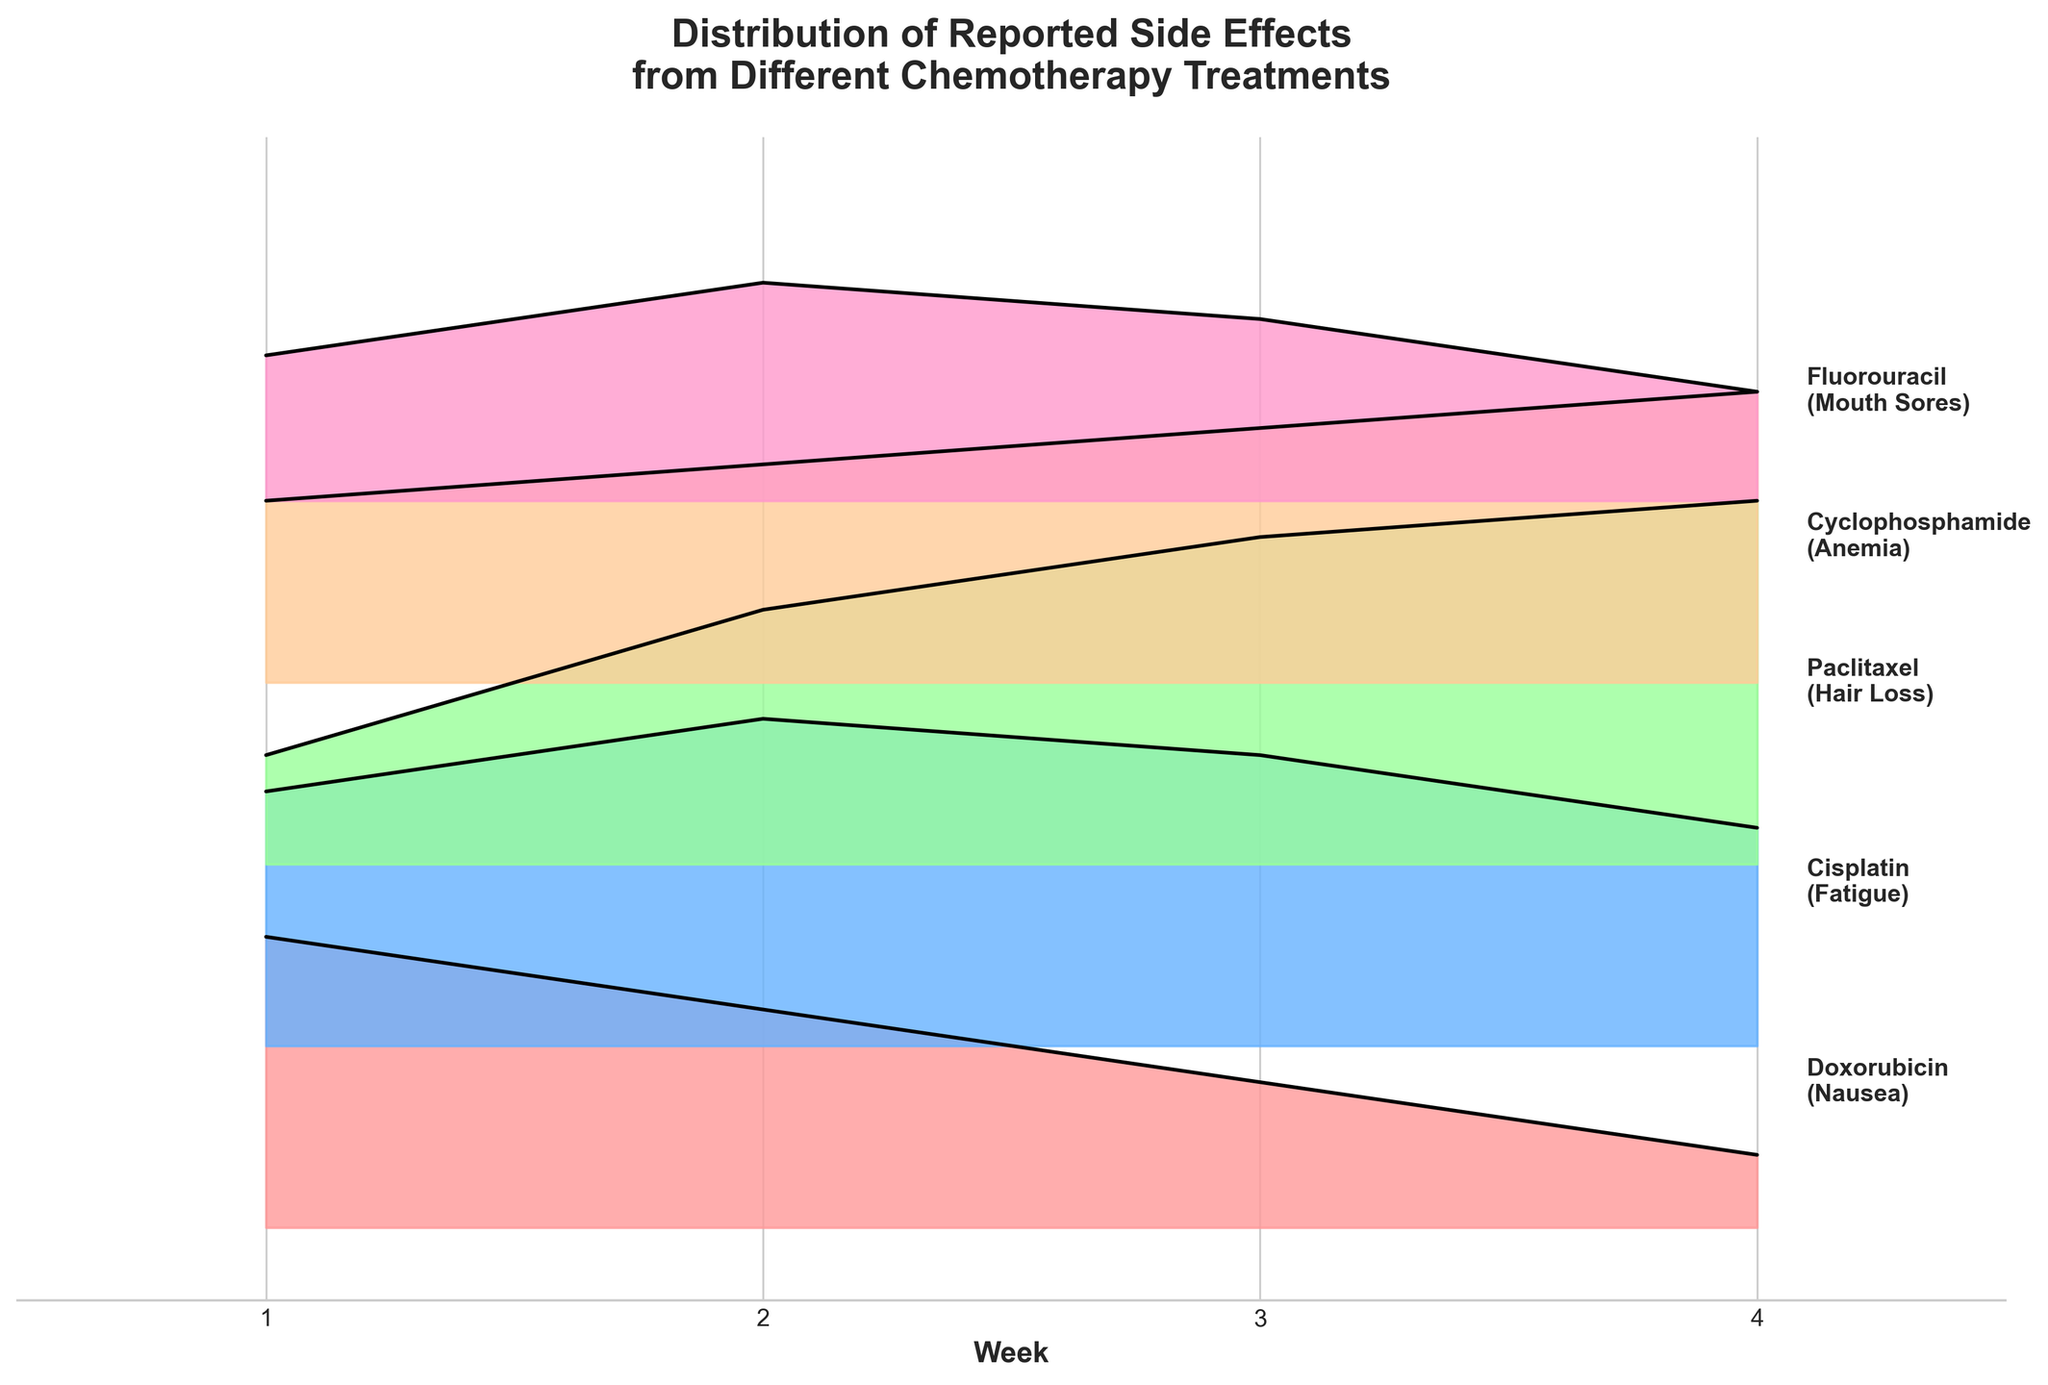What is the title of the figure? The title of the figure is located at the top of the chart, where it summarizes the main topic depicted in the plot.
Answer: Distribution of Reported Side Effects from Different Chemotherapy Treatments How many different chemotherapy treatments are depicted in the figure? Count the distinct treatments labeled along the y-axis of the plot.
Answer: 5 Which chemotherapy treatment has the highest frequency of reported side effects in Week 4? Look at the Week 4 data points and compare the frequencies for each treatment. Paclitaxel shows the highest value.
Answer: Paclitaxel What is the side effect associated with Cyclophosphamide, and how does its frequency change over the weeks? Check the label next to Cyclophosphamide to identify the side effect, and observe the change in the heights of the curves for each week. The side effect is Anemia with an increasing frequency from Week 1 to Week 4.
Answer: Anemia; increasing Which treatment has the most noticeable increase in side effect frequency from Week 1 to Week 4? Examine each treatment's side effect frequencies from Week 1 to Week 4 and find the steepest increase.
Answer: Paclitaxel Compare the frequencies of reported side effects for Doxorubicin and Fluorouracil in Week 2. Which one is higher? Identify the frequencies for both treatments in Week 2 and compare their values. Fluorouracil (0.6) and Doxorubicin (0.6).
Answer: Same Which treatments report a decrease in side effect frequencies by Week 4 compared to Week 1? Look at the frequencies for Week 4 and Week 1 for each treatment, and identify which ones have a lower frequency in Week 4.
Answer: Doxorubicin, Fluorouracil How does the shape of the frequency curve change for Cisplatin over the four weeks? Observe the curve's progression for Cisplatin from Week 1 to Week 4 to describe its shape and behavior. The shape starts high in Week 2 and decreases steadily.
Answer: Increasing, then decreasing What is the average frequency of reported side effects for Fluorouracil across the four weeks? Sum up the frequencies for each week for Fluorouracil and divide by the number of weeks, i.e., (0.4 + 0.6 + 0.5 + 0.3) / 4.
Answer: 0.45 